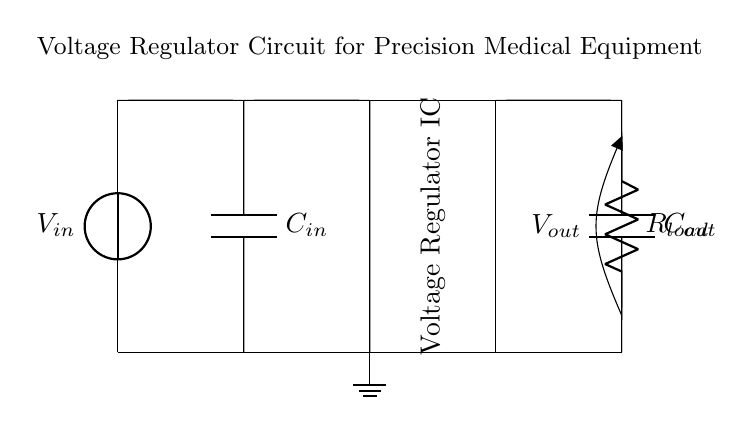What is the type of input capacitor used? The input capacitor is marked as "C_in" in the circuit diagram, which indicates that it is a capacitor specifically for input smoothing/filtering.
Answer: C_in What does the voltage regulator IC do? The voltage regulator IC stabilizes the output voltage by maintaining a constant level despite changes in input voltage or load conditions, as indicated by its function in the circuit.
Answer: Stabilizes voltage What is the role of the load resistor in this circuit? The load resistor, marked as "R_load," represents the component that draws current from the power supply, indicating the power consumption of the connected device.
Answer: Current draw What is represented by V_out in the diagram? V_out signifies the output voltage provided to the load, which is measured across the load resistor. The diagram indicates this voltage has been regulated for accurate delivery to precision medical equipment.
Answer: Output voltage If the input voltage is 12V, what is the likely function of the capacitors? Both capacitors (C_in and C_out) are used for filtering; C_in smooths the input voltage before it reaches the regulator, while C_out ensures stability and reduces noise at the output voltage.
Answer: Filtering What would happen if C_out is removed? Without C_out, the output voltage would likely become unstable due to fluctuations in current demand from the load, which could lead to performance issues in precision medical equipment.
Answer: Unstable output 